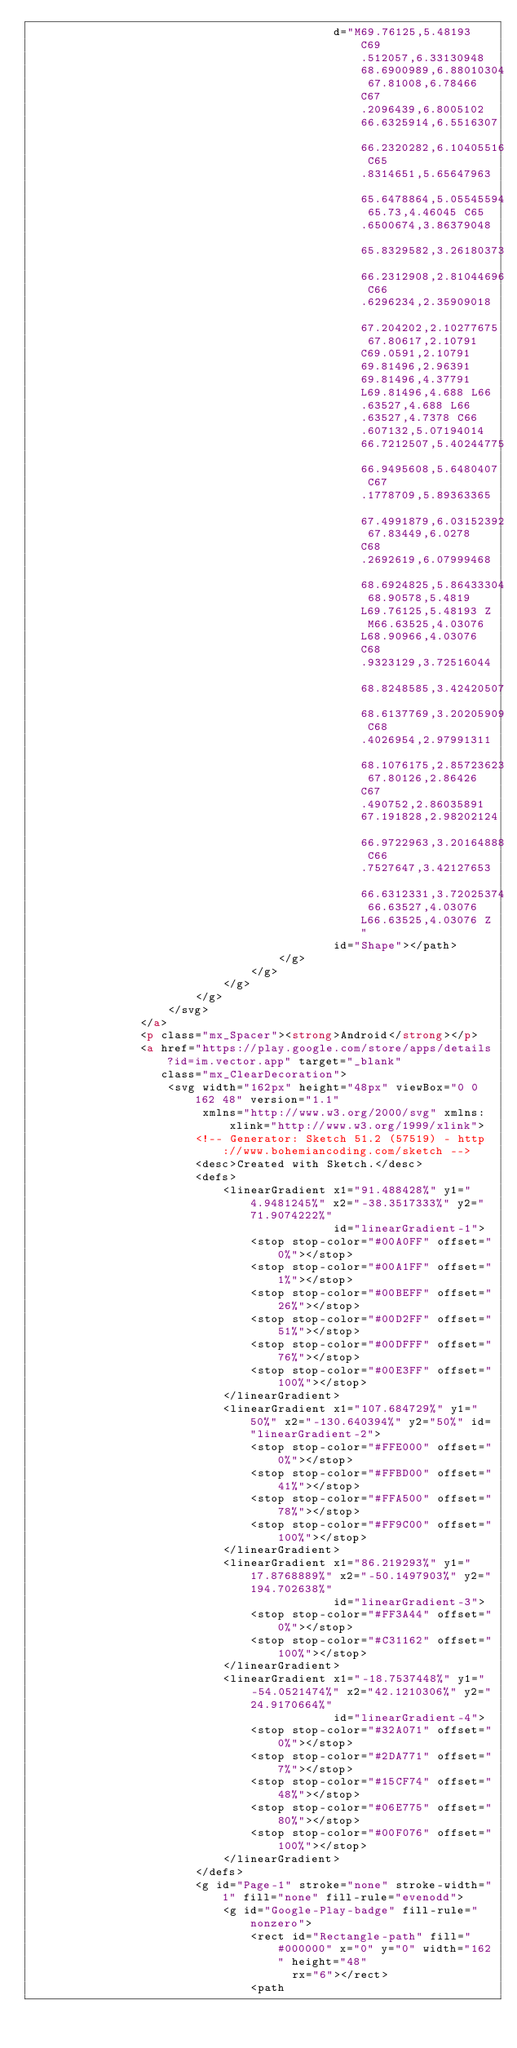<code> <loc_0><loc_0><loc_500><loc_500><_HTML_>                                            d="M69.76125,5.48193 C69.512057,6.33130948 68.6900989,6.88010304 67.81008,6.78466 C67.2096439,6.8005102 66.6325914,6.5516307 66.2320282,6.10405516 C65.8314651,5.65647963 65.6478864,5.05545594 65.73,4.46045 C65.6500674,3.86379048 65.8329582,3.26180373 66.2312908,2.81044696 C66.6296234,2.35909018 67.204202,2.10277675 67.80617,2.10791 C69.0591,2.10791 69.81496,2.96391 69.81496,4.37791 L69.81496,4.688 L66.63527,4.688 L66.63527,4.7378 C66.607132,5.07194014 66.7212507,5.40244775 66.9495608,5.6480407 C67.1778709,5.89363365 67.4991879,6.03152392 67.83449,6.0278 C68.2692619,6.07999468 68.6924825,5.86433304 68.90578,5.4819 L69.76125,5.48193 Z M66.63525,4.03076 L68.90966,4.03076 C68.9323129,3.72516044 68.8248585,3.42420507 68.6137769,3.20205909 C68.4026954,2.97991311 68.1076175,2.85723623 67.80126,2.86426 C67.490752,2.86035891 67.191828,2.98202124 66.9722963,3.20164888 C66.7527647,3.42127653 66.6312331,3.72025374 66.63527,4.03076 L66.63525,4.03076 Z"
                                            id="Shape"></path>
                                    </g>
                                </g>
                            </g>
                        </g>
                    </svg>
                </a>
                <p class="mx_Spacer"><strong>Android</strong></p>
                <a href="https://play.google.com/store/apps/details?id=im.vector.app" target="_blank"
                   class="mx_ClearDecoration">
                    <svg width="162px" height="48px" viewBox="0 0 162 48" version="1.1"
                         xmlns="http://www.w3.org/2000/svg" xmlns:xlink="http://www.w3.org/1999/xlink">
                        <!-- Generator: Sketch 51.2 (57519) - http://www.bohemiancoding.com/sketch -->
                        <desc>Created with Sketch.</desc>
                        <defs>
                            <linearGradient x1="91.488428%" y1="4.9481245%" x2="-38.3517333%" y2="71.9074222%"
                                            id="linearGradient-1">
                                <stop stop-color="#00A0FF" offset="0%"></stop>
                                <stop stop-color="#00A1FF" offset="1%"></stop>
                                <stop stop-color="#00BEFF" offset="26%"></stop>
                                <stop stop-color="#00D2FF" offset="51%"></stop>
                                <stop stop-color="#00DFFF" offset="76%"></stop>
                                <stop stop-color="#00E3FF" offset="100%"></stop>
                            </linearGradient>
                            <linearGradient x1="107.684729%" y1="50%" x2="-130.640394%" y2="50%" id="linearGradient-2">
                                <stop stop-color="#FFE000" offset="0%"></stop>
                                <stop stop-color="#FFBD00" offset="41%"></stop>
                                <stop stop-color="#FFA500" offset="78%"></stop>
                                <stop stop-color="#FF9C00" offset="100%"></stop>
                            </linearGradient>
                            <linearGradient x1="86.219293%" y1="17.8768889%" x2="-50.1497903%" y2="194.702638%"
                                            id="linearGradient-3">
                                <stop stop-color="#FF3A44" offset="0%"></stop>
                                <stop stop-color="#C31162" offset="100%"></stop>
                            </linearGradient>
                            <linearGradient x1="-18.7537448%" y1="-54.0521474%" x2="42.1210306%" y2="24.9170664%"
                                            id="linearGradient-4">
                                <stop stop-color="#32A071" offset="0%"></stop>
                                <stop stop-color="#2DA771" offset="7%"></stop>
                                <stop stop-color="#15CF74" offset="48%"></stop>
                                <stop stop-color="#06E775" offset="80%"></stop>
                                <stop stop-color="#00F076" offset="100%"></stop>
                            </linearGradient>
                        </defs>
                        <g id="Page-1" stroke="none" stroke-width="1" fill="none" fill-rule="evenodd">
                            <g id="Google-Play-badge" fill-rule="nonzero">
                                <rect id="Rectangle-path" fill="#000000" x="0" y="0" width="162" height="48"
                                      rx="6"></rect>
                                <path</code> 